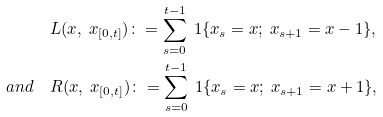Convert formula to latex. <formula><loc_0><loc_0><loc_500><loc_500>& L ( x , \ x _ { [ 0 , t ] } ) \colon = \sum _ { s = 0 } ^ { t - 1 } \ 1 \{ x _ { s } = x ; \ x _ { s + 1 } = x - 1 \} , \\ a n d \quad & R ( x , \ x _ { [ 0 , t ] } ) \colon = \sum _ { s = 0 } ^ { t - 1 } \ 1 \{ x _ { s } = x ; \ x _ { s + 1 } = x + 1 \} ,</formula> 